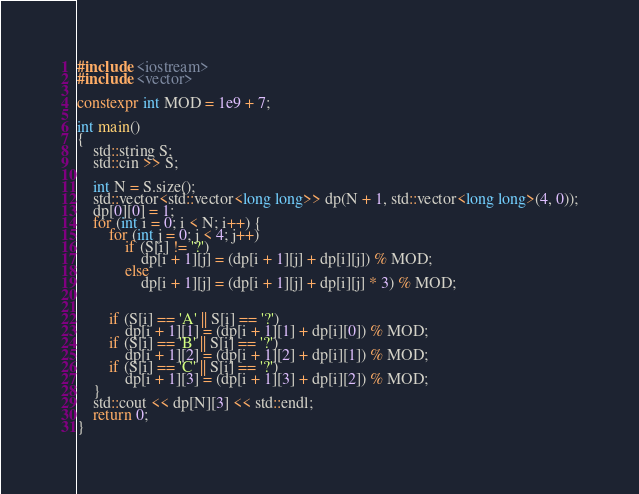<code> <loc_0><loc_0><loc_500><loc_500><_C++_>#include <iostream>
#include <vector>

constexpr int MOD = 1e9 + 7;

int main()
{
    std::string S;
    std::cin >> S;

    int N = S.size();
    std::vector<std::vector<long long>> dp(N + 1, std::vector<long long>(4, 0));
    dp[0][0] = 1;
    for (int i = 0; i < N; i++) {
        for (int j = 0; j < 4; j++)
            if (S[i] != '?')
                dp[i + 1][j] = (dp[i + 1][j] + dp[i][j]) % MOD;
            else
                dp[i + 1][j] = (dp[i + 1][j] + dp[i][j] * 3) % MOD;


        if (S[i] == 'A' || S[i] == '?')
            dp[i + 1][1] = (dp[i + 1][1] + dp[i][0]) % MOD;
        if (S[i] == 'B' || S[i] == '?')
            dp[i + 1][2] = (dp[i + 1][2] + dp[i][1]) % MOD;
        if (S[i] == 'C' || S[i] == '?')
            dp[i + 1][3] = (dp[i + 1][3] + dp[i][2]) % MOD;
    }
    std::cout << dp[N][3] << std::endl;
    return 0;
}</code> 